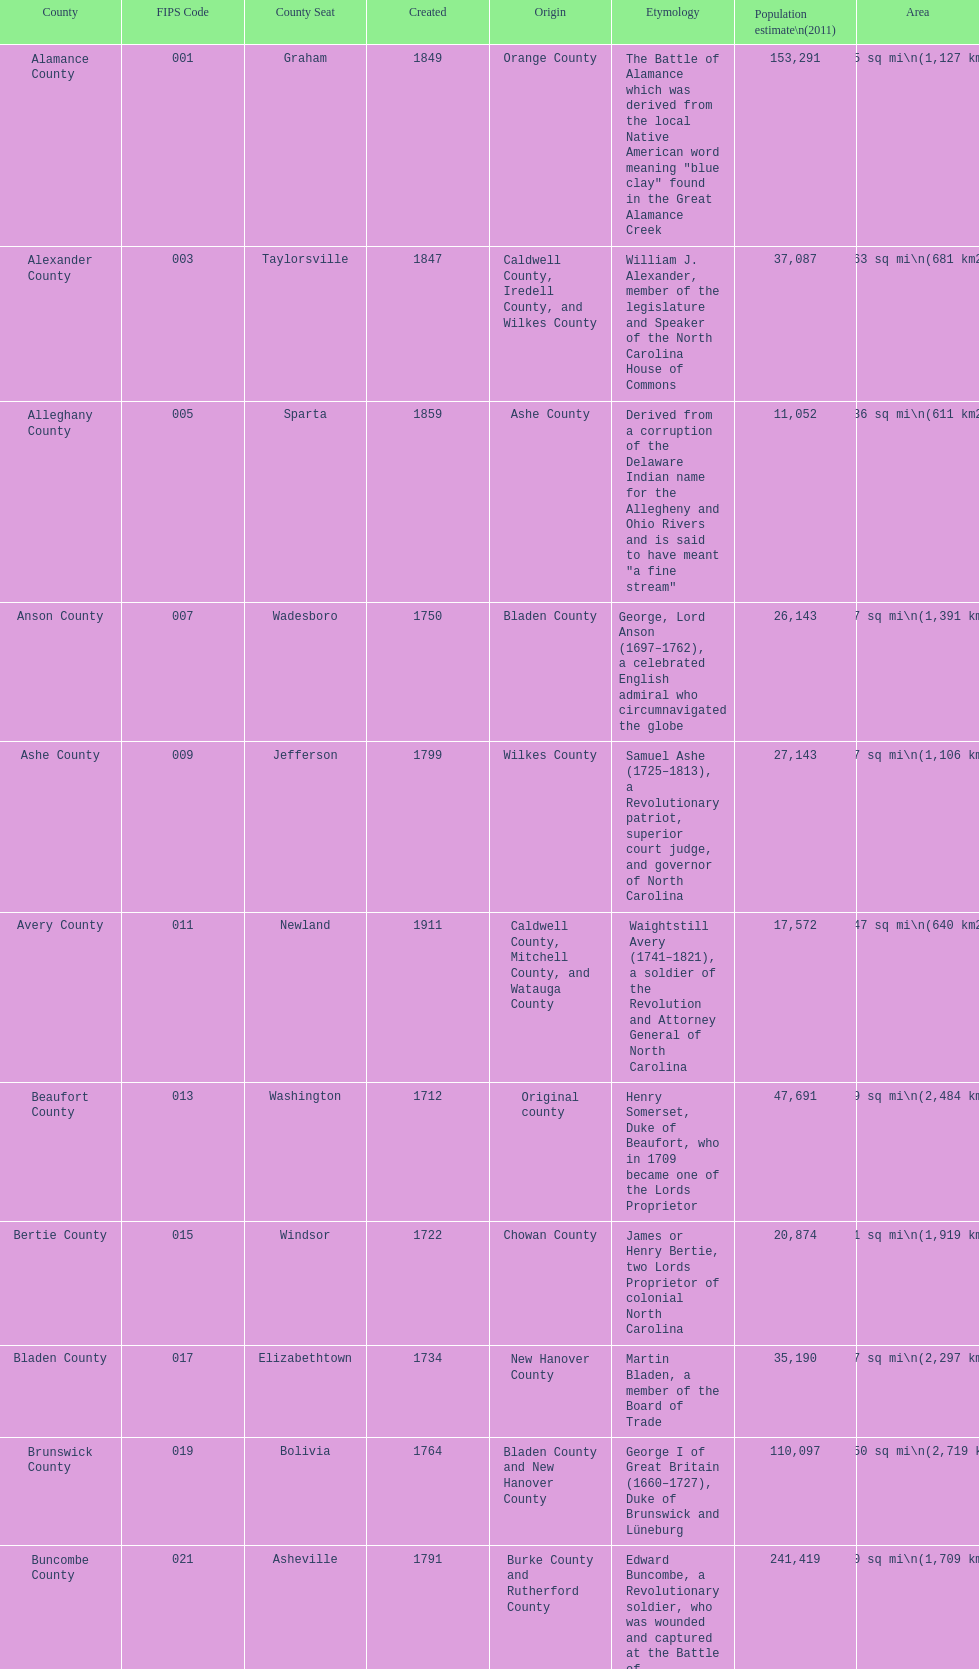Besides mecklenburg, which county has the most significant population? Wake County. 